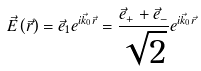<formula> <loc_0><loc_0><loc_500><loc_500>\vec { E } \left ( \vec { r } \right ) = \vec { e } _ { 1 } e ^ { i \vec { k } _ { 0 } \vec { r } } = \frac { \vec { e } _ { + } + \vec { e } _ { - } } { \sqrt { 2 } } e ^ { i \vec { k } _ { 0 } \vec { r } }</formula> 